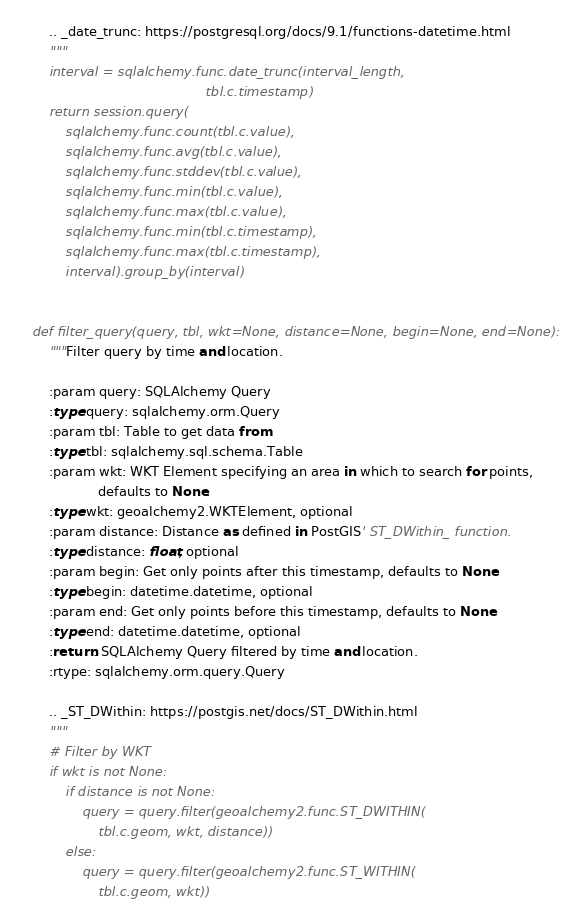<code> <loc_0><loc_0><loc_500><loc_500><_Python_>
    .. _date_trunc: https://postgresql.org/docs/9.1/functions-datetime.html
    """
    interval = sqlalchemy.func.date_trunc(interval_length,
                                          tbl.c.timestamp)
    return session.query(
        sqlalchemy.func.count(tbl.c.value),
        sqlalchemy.func.avg(tbl.c.value),
        sqlalchemy.func.stddev(tbl.c.value),
        sqlalchemy.func.min(tbl.c.value),
        sqlalchemy.func.max(tbl.c.value),
        sqlalchemy.func.min(tbl.c.timestamp),
        sqlalchemy.func.max(tbl.c.timestamp),
        interval).group_by(interval)


def filter_query(query, tbl, wkt=None, distance=None, begin=None, end=None):
    """Filter query by time and location.

    :param query: SQLAlchemy Query
    :type query: sqlalchemy.orm.Query
    :param tbl: Table to get data from
    :type tbl: sqlalchemy.sql.schema.Table
    :param wkt: WKT Element specifying an area in which to search for points,
                defaults to None.
    :type wkt: geoalchemy2.WKTElement, optional
    :param distance: Distance as defined in PostGIS' ST_DWithin_ function.
    :type distance: float, optional
    :param begin: Get only points after this timestamp, defaults to None
    :type begin: datetime.datetime, optional
    :param end: Get only points before this timestamp, defaults to None
    :type end: datetime.datetime, optional
    :return: SQLAlchemy Query filtered by time and location.
    :rtype: sqlalchemy.orm.query.Query

    .. _ST_DWithin: https://postgis.net/docs/ST_DWithin.html
    """
    # Filter by WKT
    if wkt is not None:
        if distance is not None:
            query = query.filter(geoalchemy2.func.ST_DWITHIN(
                tbl.c.geom, wkt, distance))
        else:
            query = query.filter(geoalchemy2.func.ST_WITHIN(
                tbl.c.geom, wkt))
</code> 